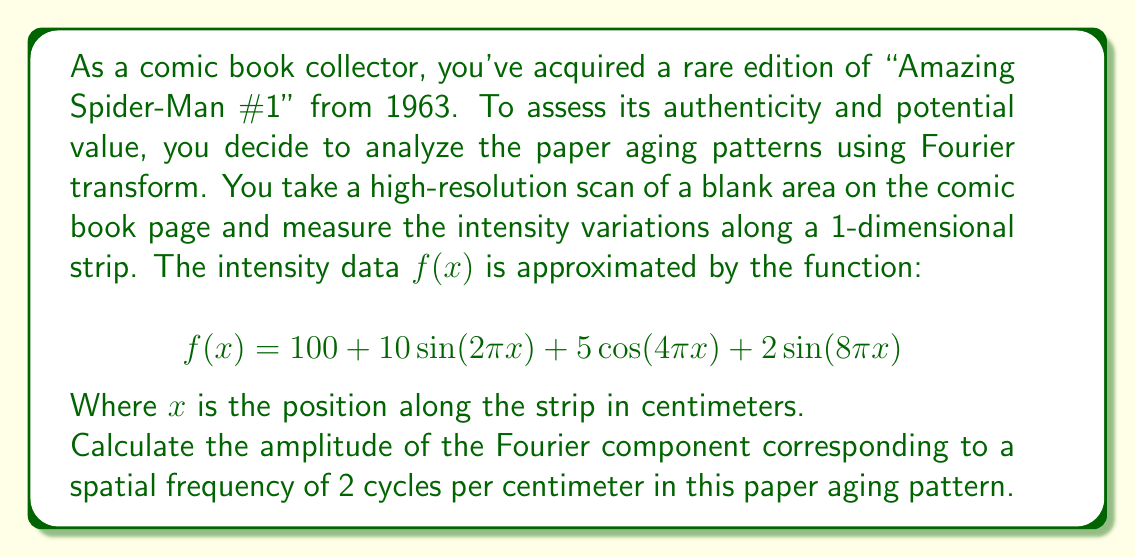Give your solution to this math problem. To solve this problem, we need to use the Fourier transform to analyze the given function. The Fourier transform decomposes a function into its constituent frequencies. In this case, we're looking for the amplitude of a specific spatial frequency.

1) First, let's identify the terms in the given function:
   $$f(x) = 100 + 10\sin(2\pi x) + 5\cos(4\pi x) + 2\sin(8\pi x)$$

2) The general form of a sinusoidal function is $A\sin(2\pi fx + \phi)$ or $A\cos(2\pi fx + \phi)$, where:
   - $A$ is the amplitude
   - $f$ is the frequency
   - $\phi$ is the phase shift

3) Looking at our function:
   - $10\sin(2\pi x)$ has a frequency of 1 cycle/cm
   - $5\cos(4\pi x)$ has a frequency of 2 cycles/cm
   - $2\sin(8\pi x)$ has a frequency of 4 cycles/cm

4) We're asked about the component with a spatial frequency of 2 cycles/cm. This corresponds to the term $5\cos(4\pi x)$.

5) The amplitude of this component is 5.

Therefore, the amplitude of the Fourier component corresponding to a spatial frequency of 2 cycles per centimeter is 5.
Answer: 5 